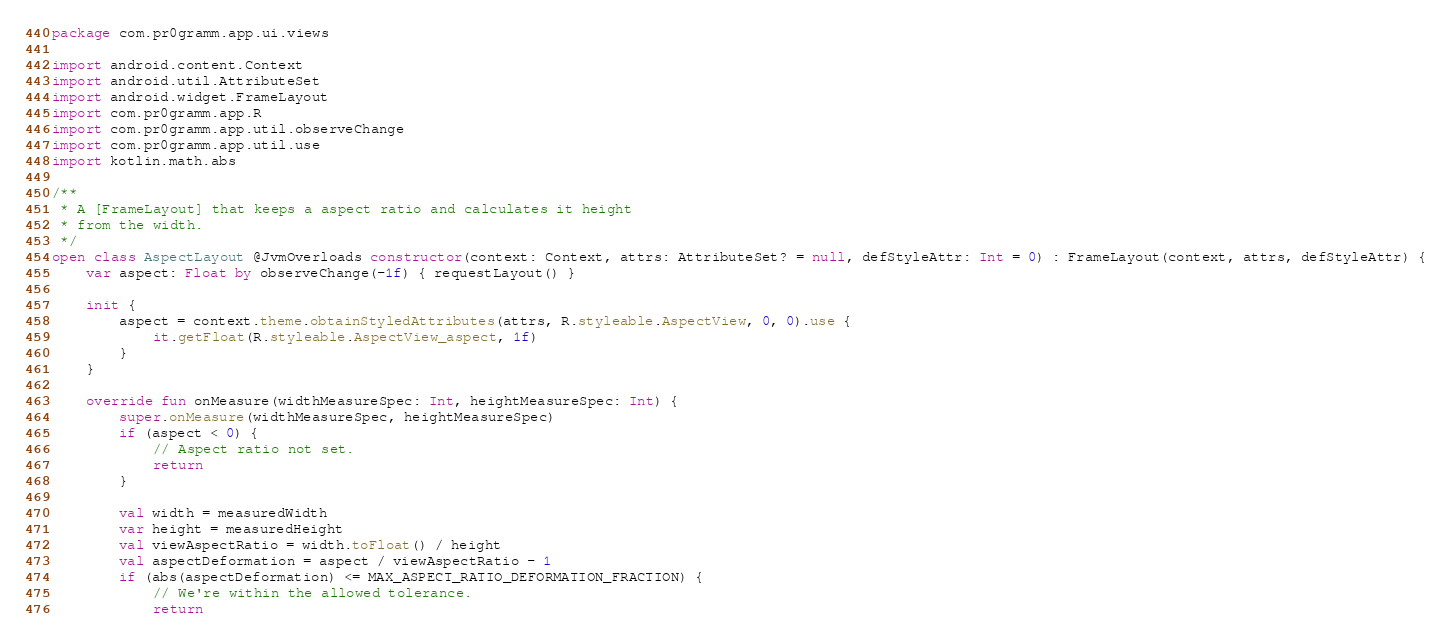Convert code to text. <code><loc_0><loc_0><loc_500><loc_500><_Kotlin_>package com.pr0gramm.app.ui.views

import android.content.Context
import android.util.AttributeSet
import android.widget.FrameLayout
import com.pr0gramm.app.R
import com.pr0gramm.app.util.observeChange
import com.pr0gramm.app.util.use
import kotlin.math.abs

/**
 * A [FrameLayout] that keeps a aspect ratio and calculates it height
 * from the width.
 */
open class AspectLayout @JvmOverloads constructor(context: Context, attrs: AttributeSet? = null, defStyleAttr: Int = 0) : FrameLayout(context, attrs, defStyleAttr) {
    var aspect: Float by observeChange(-1f) { requestLayout() }

    init {
        aspect = context.theme.obtainStyledAttributes(attrs, R.styleable.AspectView, 0, 0).use {
            it.getFloat(R.styleable.AspectView_aspect, 1f)
        }
    }

    override fun onMeasure(widthMeasureSpec: Int, heightMeasureSpec: Int) {
        super.onMeasure(widthMeasureSpec, heightMeasureSpec)
        if (aspect < 0) {
            // Aspect ratio not set.
            return
        }

        val width = measuredWidth
        var height = measuredHeight
        val viewAspectRatio = width.toFloat() / height
        val aspectDeformation = aspect / viewAspectRatio - 1
        if (abs(aspectDeformation) <= MAX_ASPECT_RATIO_DEFORMATION_FRACTION) {
            // We're within the allowed tolerance.
            return</code> 